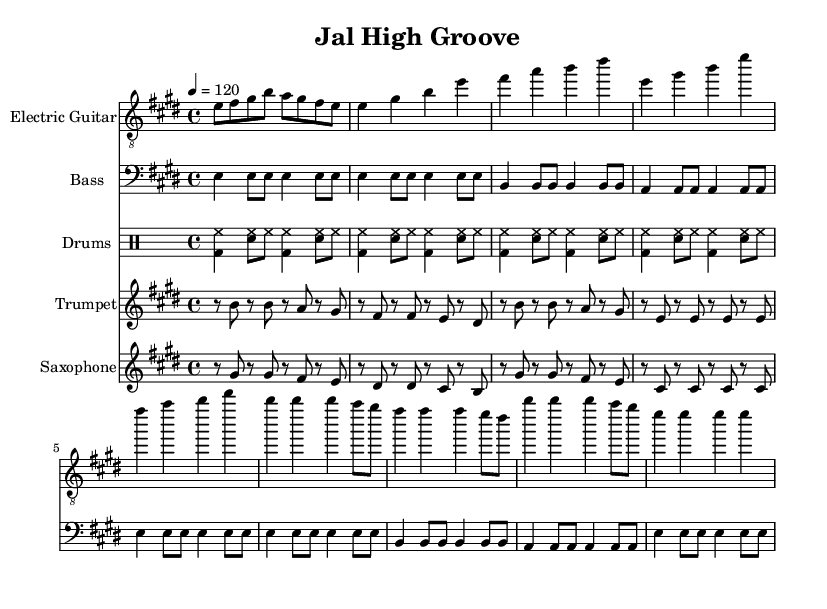What is the key signature of this music? The key signature is indicated at the beginning of the sheet music, showing two sharps (F# and C#), which confirms that the key is E major.
Answer: E major What is the time signature of this music? The time signature is displayed at the beginning of the sheet music. It is written as 4/4, indicating that there are four beats in each measure and the quarter note gets one beat.
Answer: 4/4 What is the tempo marking of this piece? The tempo is notated as "4 = 120" at the beginning of the sheet music. This means there are 120 beats per minute, indicating a moderate fast pace.
Answer: 120 How many measures are in the Intro section? By counting the number of measures in the electric guitar part provided, we can note that there are four measures in the Intro section.
Answer: 4 What instruments are featured in this piece? The instruments are listed at the start of each staff section in the score. The featured instruments are Electric Guitar, Bass, Drums, Trumpet, and Saxophone.
Answer: Electric Guitar, Bass, Drums, Trumpet, Saxophone What rhythmic device is used in the drum part? The drum part employs a basic funk rock pattern characterized by a combination of bass drum and snare hits alternating with hi-hat played on the offbeats.
Answer: Funk rock pattern Which section of the piece features the trumpet and saxophone playing offbeats? Both the trumpet and saxophone sections include offbeat brass stabs during the Chorus section, where syncopation creates a lively effect typical in funk music.
Answer: Chorus 